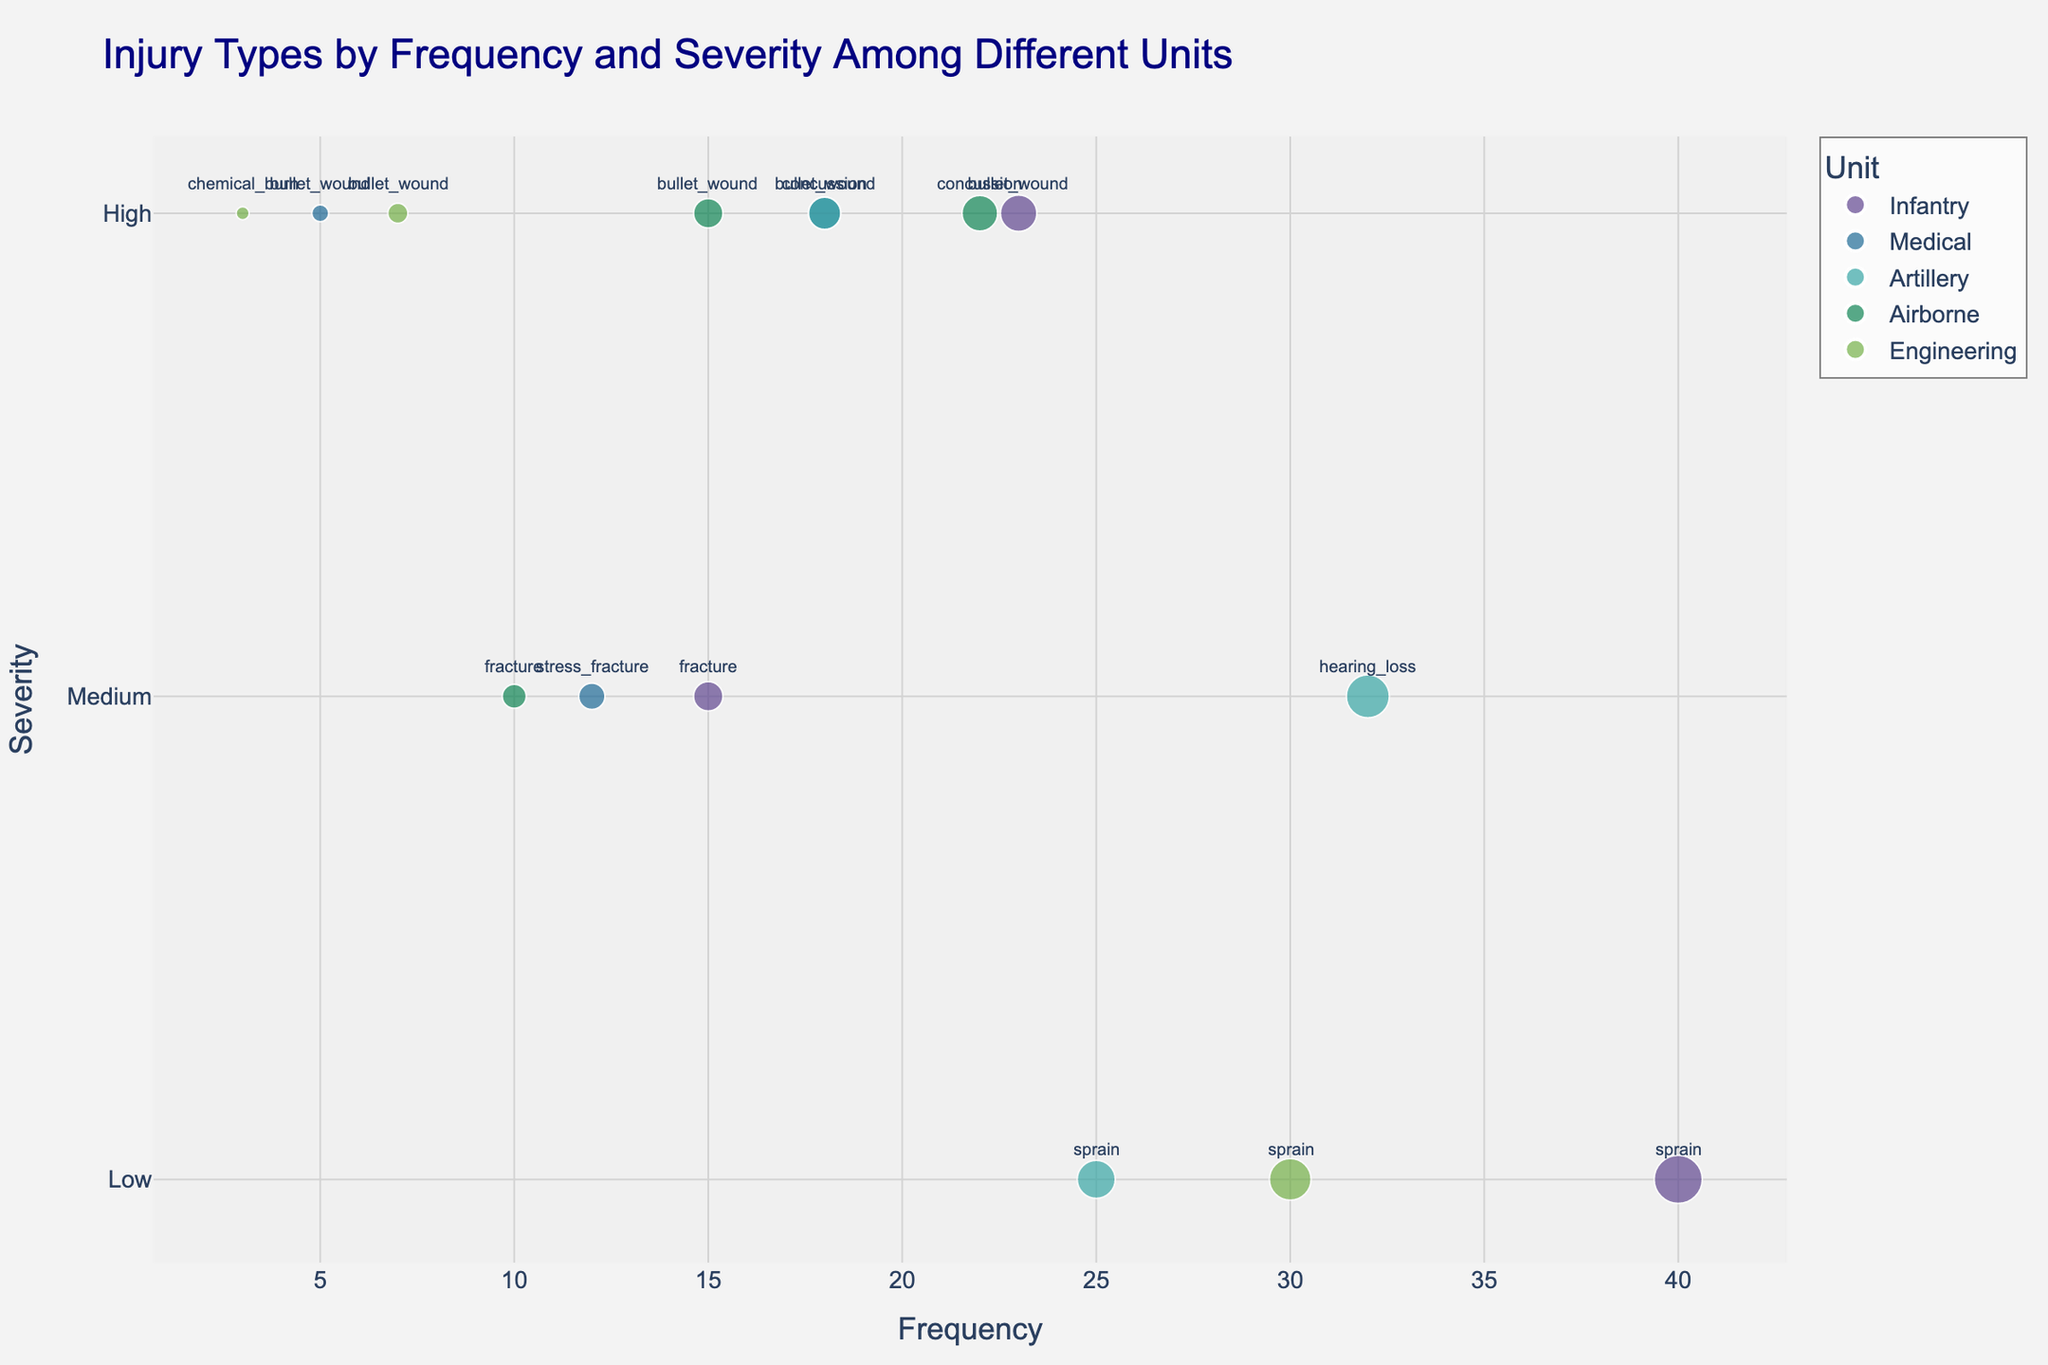What's the most common injury type for the Infantry unit? By examining the plot, you'll see the Infantry unit data points and their frequencies. The injury type with the highest frequency value is 'sprain' with a frequency of 40.
Answer: sprain How does the frequency of bullet wounds in Infantry compare to Airborne? Look for the bullet wound injury type data points for the Infantry and Airborne units. The frequencies are 23 for Infantry and 15 for Airborne.
Answer: Infantry Which unit has the highest frequency of high-severity injuries? Identify all the data points mapped to high severity (y-axis value of 3). By summing the frequencies for each unit, you find Infantry: 23, Medical: 23, Artillery: 18, Airborne: 37, Engineering: 10. Thus, Airborne has the highest frequency.
Answer: Airborne What is the combined frequency of medium-severity injuries across all units? Sum the frequencies of all injuries corresponding to the 'medium' severity level (y-axis value of 2). Those are: Infantry (15), Medical (12), Artillery (32), Airborne (10). Sum of these is: 15 + 12 + 32 + 10 = 69.
Answer: 69 Which unit reported the highest-frequency injury of medium severity? Focus on medium severity points (y-axis value of 2). Among them, the highest frequency is 32 for Artillery (hearing_loss).
Answer: Artillery How many units reported chemical burns, and what's their severity level? Look at the data points related to the 'chemical_burn'. It appears only in the Engineering unit with a high severity level (y-axis value of 3).
Answer: One unit, high Compare the frequency of sprains between Infantry and Engineering units. Find the data points for 'sprain' in both Infantry and Engineering units. Infantry shows a frequency of 40 and Engineering shows a frequency of 30.
Answer: Infantry What's the total frequency of low-severity injuries across all units? Add up the frequencies of injuries with low severity (y-axis value of 1). These are: Infantry (40), Artillery (25), Engineering (30). Sum is 40 + 25 + 30 = 95.
Answer: 95 Which injury type has the highest frequency overall, and which unit does it belong to? Identify the data points with the highest frequency value. The highest is 'sprain' at 40, belonging to the Infantry unit.
Answer: sprain, Infantry 